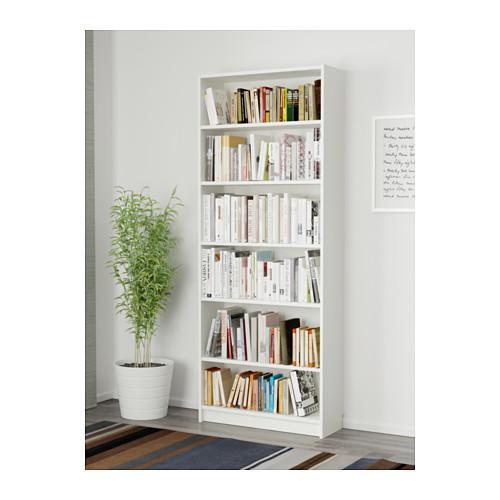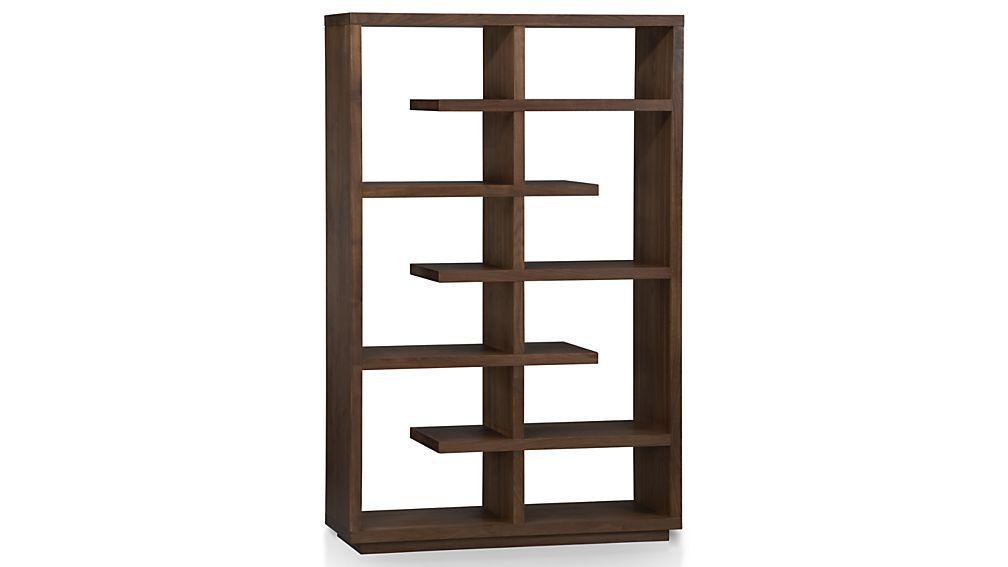The first image is the image on the left, the second image is the image on the right. Considering the images on both sides, is "One tall narrow bookcase is on short legs and one is flush to the floor." valid? Answer yes or no. No. 